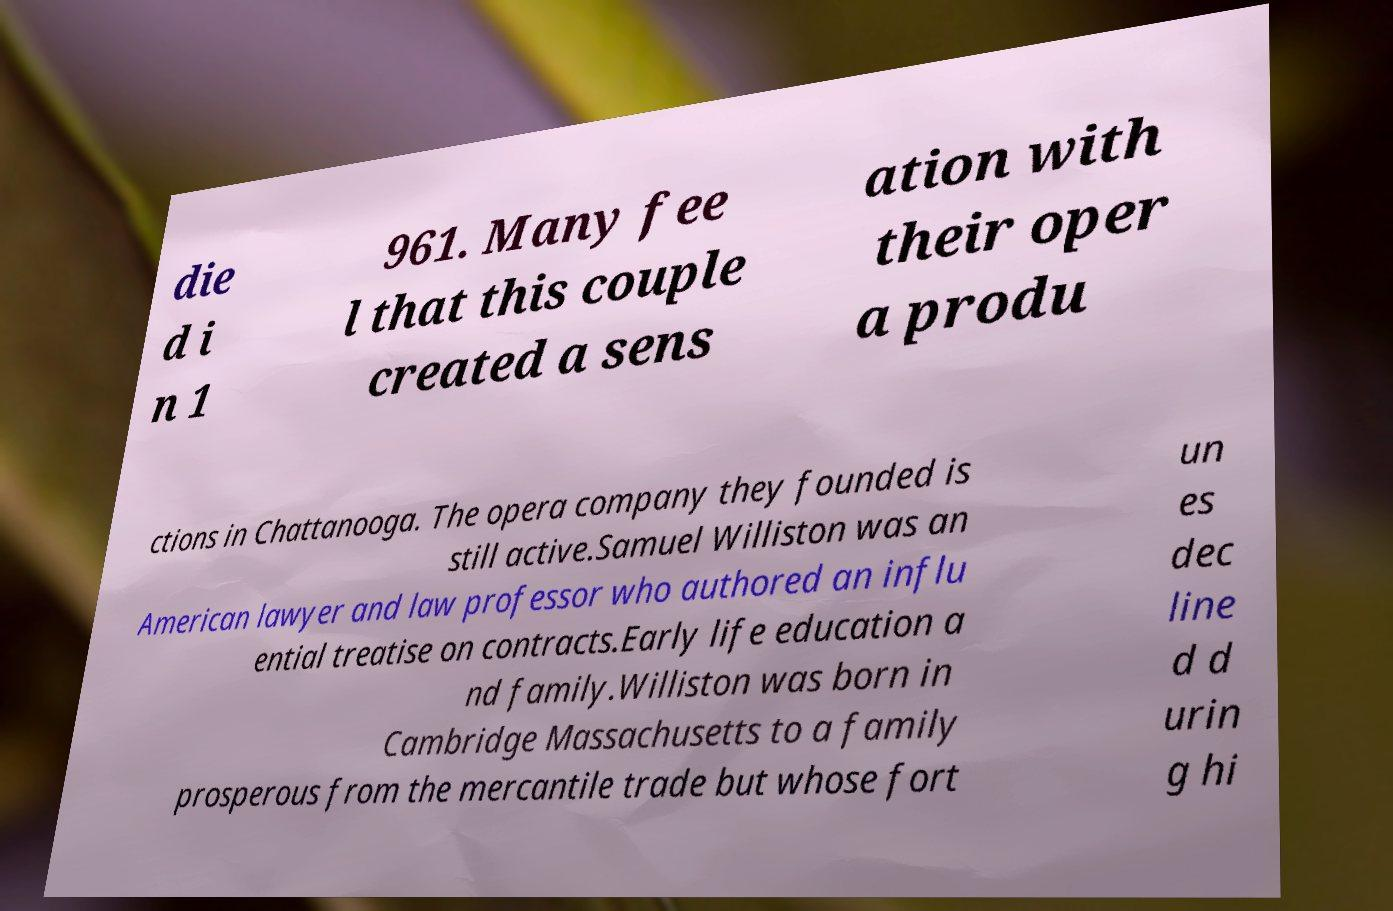What messages or text are displayed in this image? I need them in a readable, typed format. die d i n 1 961. Many fee l that this couple created a sens ation with their oper a produ ctions in Chattanooga. The opera company they founded is still active.Samuel Williston was an American lawyer and law professor who authored an influ ential treatise on contracts.Early life education a nd family.Williston was born in Cambridge Massachusetts to a family prosperous from the mercantile trade but whose fort un es dec line d d urin g hi 